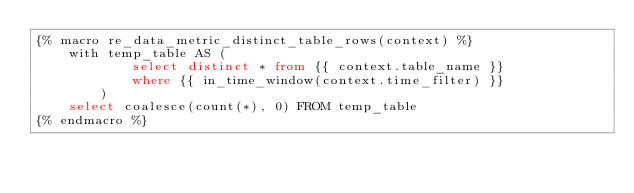Convert code to text. <code><loc_0><loc_0><loc_500><loc_500><_SQL_>{% macro re_data_metric_distinct_table_rows(context) %}
    with temp_table AS (
            select distinct * from {{ context.table_name }}
            where {{ in_time_window(context.time_filter) }}
        )
    select coalesce(count(*), 0) FROM temp_table
{% endmacro %}
</code> 